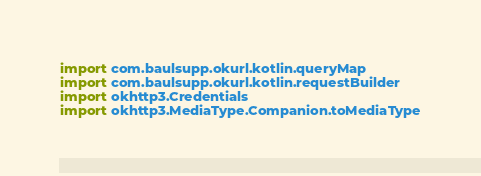Convert code to text. <code><loc_0><loc_0><loc_500><loc_500><_Kotlin_>import com.baulsupp.okurl.kotlin.queryMap
import com.baulsupp.okurl.kotlin.requestBuilder
import okhttp3.Credentials
import okhttp3.MediaType.Companion.toMediaType</code> 